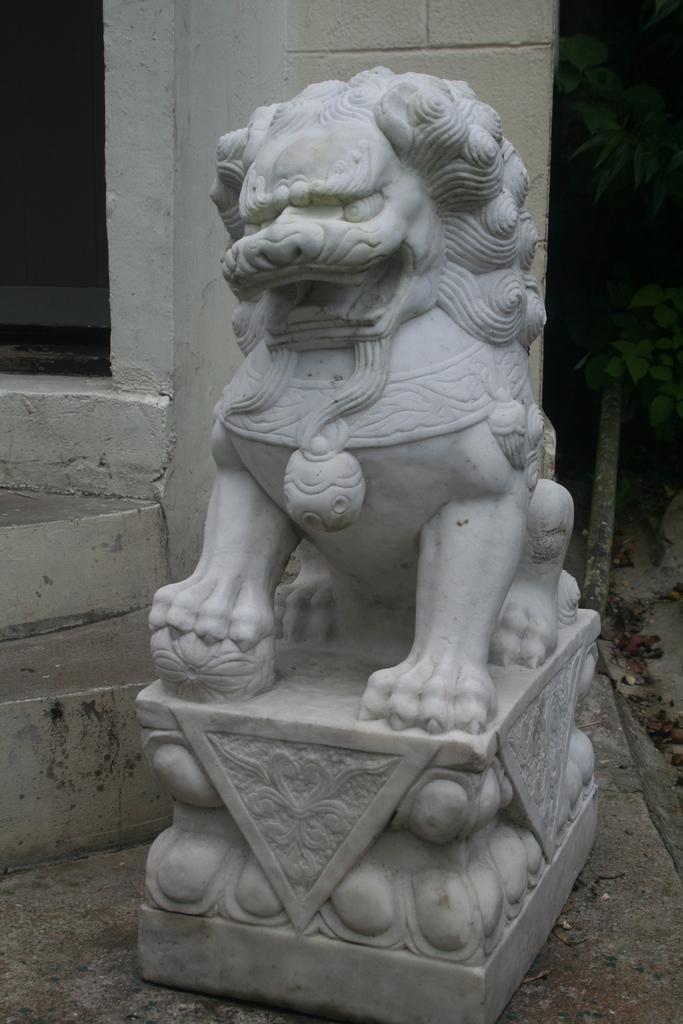Can you describe this image briefly? In this picture we can see a sculpture in the front, on the right side there is a plant, in the background there is a wall. 